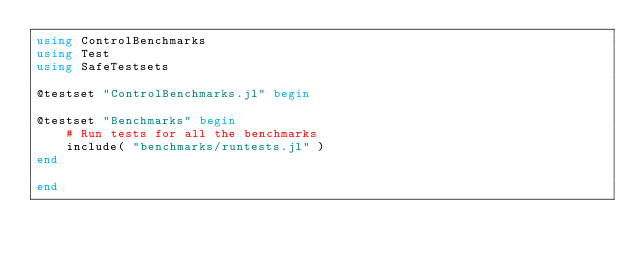<code> <loc_0><loc_0><loc_500><loc_500><_Julia_>using ControlBenchmarks
using Test
using SafeTestsets

@testset "ControlBenchmarks.jl" begin

@testset "Benchmarks" begin
    # Run tests for all the benchmarks
    include( "benchmarks/runtests.jl" )
end

end
</code> 